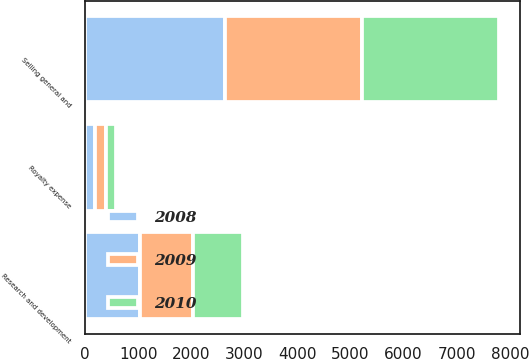<chart> <loc_0><loc_0><loc_500><loc_500><stacked_bar_chart><ecel><fcel>Selling general and<fcel>Research and development<fcel>Royalty expense<nl><fcel>2010<fcel>2580<fcel>939<fcel>185<nl><fcel>2008<fcel>2635<fcel>1035<fcel>191<nl><fcel>2009<fcel>2589<fcel>1006<fcel>203<nl></chart> 